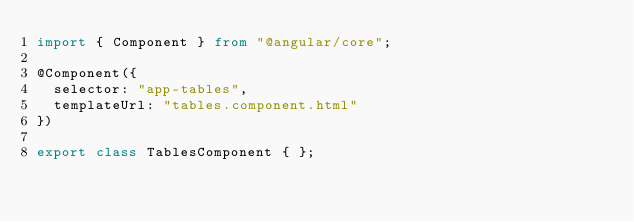Convert code to text. <code><loc_0><loc_0><loc_500><loc_500><_TypeScript_>import { Component } from "@angular/core";

@Component({
  selector: "app-tables",
  templateUrl: "tables.component.html"
})

export class TablesComponent { };
</code> 